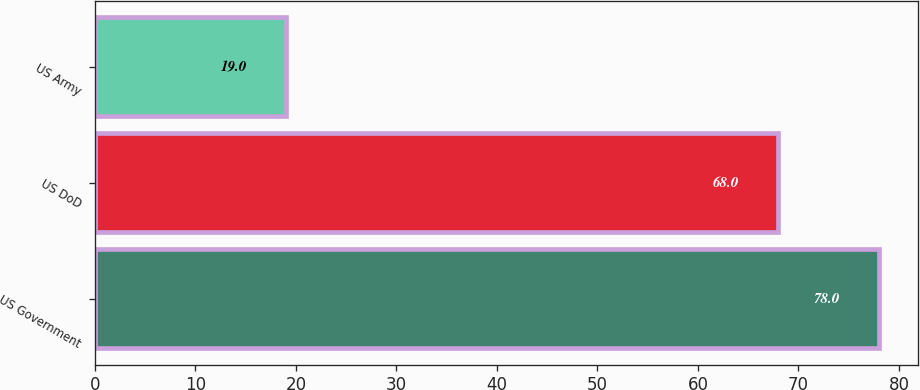<chart> <loc_0><loc_0><loc_500><loc_500><bar_chart><fcel>US Government<fcel>US DoD<fcel>US Army<nl><fcel>78<fcel>68<fcel>19<nl></chart> 